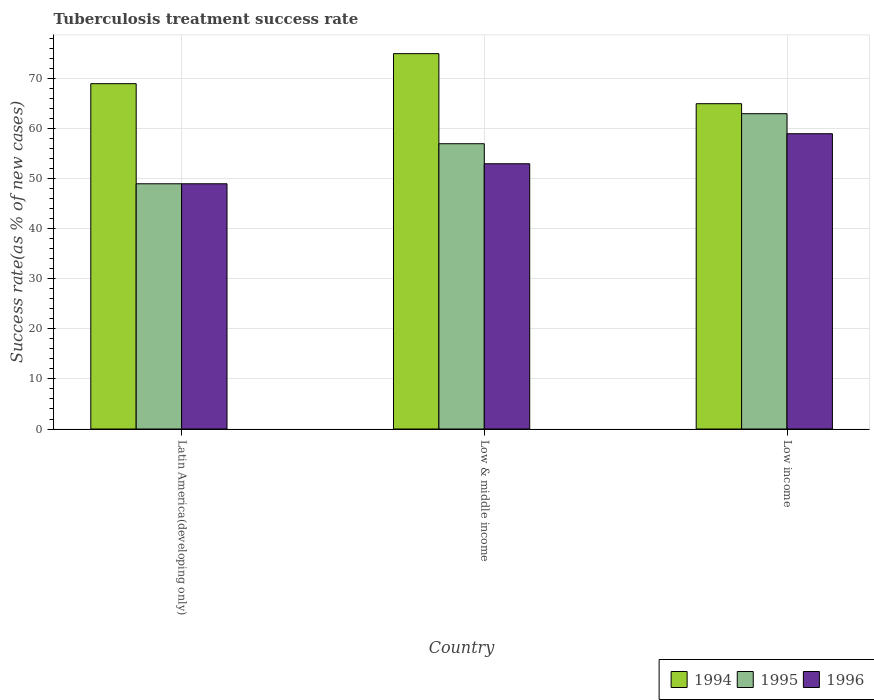How many groups of bars are there?
Give a very brief answer. 3. Are the number of bars on each tick of the X-axis equal?
Offer a terse response. Yes. What is the label of the 2nd group of bars from the left?
Keep it short and to the point. Low & middle income. In how many cases, is the number of bars for a given country not equal to the number of legend labels?
Offer a very short reply. 0. What is the tuberculosis treatment success rate in 1994 in Low & middle income?
Offer a terse response. 75. Across all countries, what is the maximum tuberculosis treatment success rate in 1994?
Ensure brevity in your answer.  75. Across all countries, what is the minimum tuberculosis treatment success rate in 1995?
Keep it short and to the point. 49. In which country was the tuberculosis treatment success rate in 1994 maximum?
Keep it short and to the point. Low & middle income. In which country was the tuberculosis treatment success rate in 1995 minimum?
Your answer should be compact. Latin America(developing only). What is the total tuberculosis treatment success rate in 1994 in the graph?
Give a very brief answer. 209. What is the difference between the tuberculosis treatment success rate in 1995 in Latin America(developing only) and that in Low & middle income?
Give a very brief answer. -8. What is the average tuberculosis treatment success rate in 1996 per country?
Your response must be concise. 53.67. What is the ratio of the tuberculosis treatment success rate in 1995 in Latin America(developing only) to that in Low & middle income?
Ensure brevity in your answer.  0.86. Is the tuberculosis treatment success rate in 1994 in Latin America(developing only) less than that in Low income?
Make the answer very short. No. Is the difference between the tuberculosis treatment success rate in 1994 in Latin America(developing only) and Low & middle income greater than the difference between the tuberculosis treatment success rate in 1995 in Latin America(developing only) and Low & middle income?
Offer a very short reply. Yes. What is the difference between the highest and the second highest tuberculosis treatment success rate in 1995?
Make the answer very short. 8. Is the sum of the tuberculosis treatment success rate in 1996 in Low & middle income and Low income greater than the maximum tuberculosis treatment success rate in 1995 across all countries?
Give a very brief answer. Yes. What does the 2nd bar from the left in Latin America(developing only) represents?
Keep it short and to the point. 1995. What does the 3rd bar from the right in Low & middle income represents?
Keep it short and to the point. 1994. How many countries are there in the graph?
Give a very brief answer. 3. What is the difference between two consecutive major ticks on the Y-axis?
Your answer should be compact. 10. Does the graph contain any zero values?
Provide a short and direct response. No. How are the legend labels stacked?
Offer a very short reply. Horizontal. What is the title of the graph?
Your answer should be very brief. Tuberculosis treatment success rate. What is the label or title of the Y-axis?
Offer a very short reply. Success rate(as % of new cases). What is the Success rate(as % of new cases) in 1994 in Latin America(developing only)?
Offer a terse response. 69. What is the Success rate(as % of new cases) in 1995 in Latin America(developing only)?
Offer a terse response. 49. What is the Success rate(as % of new cases) of 1996 in Latin America(developing only)?
Ensure brevity in your answer.  49. What is the Success rate(as % of new cases) of 1995 in Low & middle income?
Make the answer very short. 57. What is the Success rate(as % of new cases) in 1996 in Low & middle income?
Provide a succinct answer. 53. What is the Success rate(as % of new cases) in 1994 in Low income?
Keep it short and to the point. 65. What is the Success rate(as % of new cases) of 1995 in Low income?
Keep it short and to the point. 63. What is the Success rate(as % of new cases) in 1996 in Low income?
Your answer should be very brief. 59. Across all countries, what is the maximum Success rate(as % of new cases) in 1996?
Provide a succinct answer. 59. Across all countries, what is the minimum Success rate(as % of new cases) in 1994?
Make the answer very short. 65. What is the total Success rate(as % of new cases) in 1994 in the graph?
Provide a succinct answer. 209. What is the total Success rate(as % of new cases) of 1995 in the graph?
Keep it short and to the point. 169. What is the total Success rate(as % of new cases) of 1996 in the graph?
Make the answer very short. 161. What is the difference between the Success rate(as % of new cases) of 1994 in Latin America(developing only) and that in Low & middle income?
Offer a very short reply. -6. What is the difference between the Success rate(as % of new cases) in 1995 in Latin America(developing only) and that in Low & middle income?
Ensure brevity in your answer.  -8. What is the difference between the Success rate(as % of new cases) of 1996 in Latin America(developing only) and that in Low & middle income?
Offer a very short reply. -4. What is the difference between the Success rate(as % of new cases) of 1995 in Latin America(developing only) and that in Low income?
Your response must be concise. -14. What is the difference between the Success rate(as % of new cases) of 1996 in Latin America(developing only) and that in Low income?
Give a very brief answer. -10. What is the difference between the Success rate(as % of new cases) of 1994 in Low & middle income and that in Low income?
Provide a short and direct response. 10. What is the difference between the Success rate(as % of new cases) of 1996 in Low & middle income and that in Low income?
Offer a very short reply. -6. What is the difference between the Success rate(as % of new cases) of 1994 in Latin America(developing only) and the Success rate(as % of new cases) of 1996 in Low & middle income?
Give a very brief answer. 16. What is the difference between the Success rate(as % of new cases) of 1995 in Latin America(developing only) and the Success rate(as % of new cases) of 1996 in Low & middle income?
Keep it short and to the point. -4. What is the difference between the Success rate(as % of new cases) in 1994 in Latin America(developing only) and the Success rate(as % of new cases) in 1996 in Low income?
Your answer should be very brief. 10. What is the difference between the Success rate(as % of new cases) in 1995 in Low & middle income and the Success rate(as % of new cases) in 1996 in Low income?
Ensure brevity in your answer.  -2. What is the average Success rate(as % of new cases) in 1994 per country?
Provide a succinct answer. 69.67. What is the average Success rate(as % of new cases) of 1995 per country?
Provide a succinct answer. 56.33. What is the average Success rate(as % of new cases) in 1996 per country?
Your answer should be very brief. 53.67. What is the difference between the Success rate(as % of new cases) in 1995 and Success rate(as % of new cases) in 1996 in Low & middle income?
Make the answer very short. 4. What is the difference between the Success rate(as % of new cases) of 1994 and Success rate(as % of new cases) of 1995 in Low income?
Keep it short and to the point. 2. What is the difference between the Success rate(as % of new cases) of 1995 and Success rate(as % of new cases) of 1996 in Low income?
Offer a very short reply. 4. What is the ratio of the Success rate(as % of new cases) of 1995 in Latin America(developing only) to that in Low & middle income?
Make the answer very short. 0.86. What is the ratio of the Success rate(as % of new cases) in 1996 in Latin America(developing only) to that in Low & middle income?
Your answer should be compact. 0.92. What is the ratio of the Success rate(as % of new cases) of 1994 in Latin America(developing only) to that in Low income?
Keep it short and to the point. 1.06. What is the ratio of the Success rate(as % of new cases) in 1996 in Latin America(developing only) to that in Low income?
Your answer should be very brief. 0.83. What is the ratio of the Success rate(as % of new cases) of 1994 in Low & middle income to that in Low income?
Your answer should be compact. 1.15. What is the ratio of the Success rate(as % of new cases) of 1995 in Low & middle income to that in Low income?
Offer a terse response. 0.9. What is the ratio of the Success rate(as % of new cases) in 1996 in Low & middle income to that in Low income?
Offer a very short reply. 0.9. What is the difference between the highest and the second highest Success rate(as % of new cases) in 1996?
Your answer should be very brief. 6. What is the difference between the highest and the lowest Success rate(as % of new cases) in 1994?
Ensure brevity in your answer.  10. 